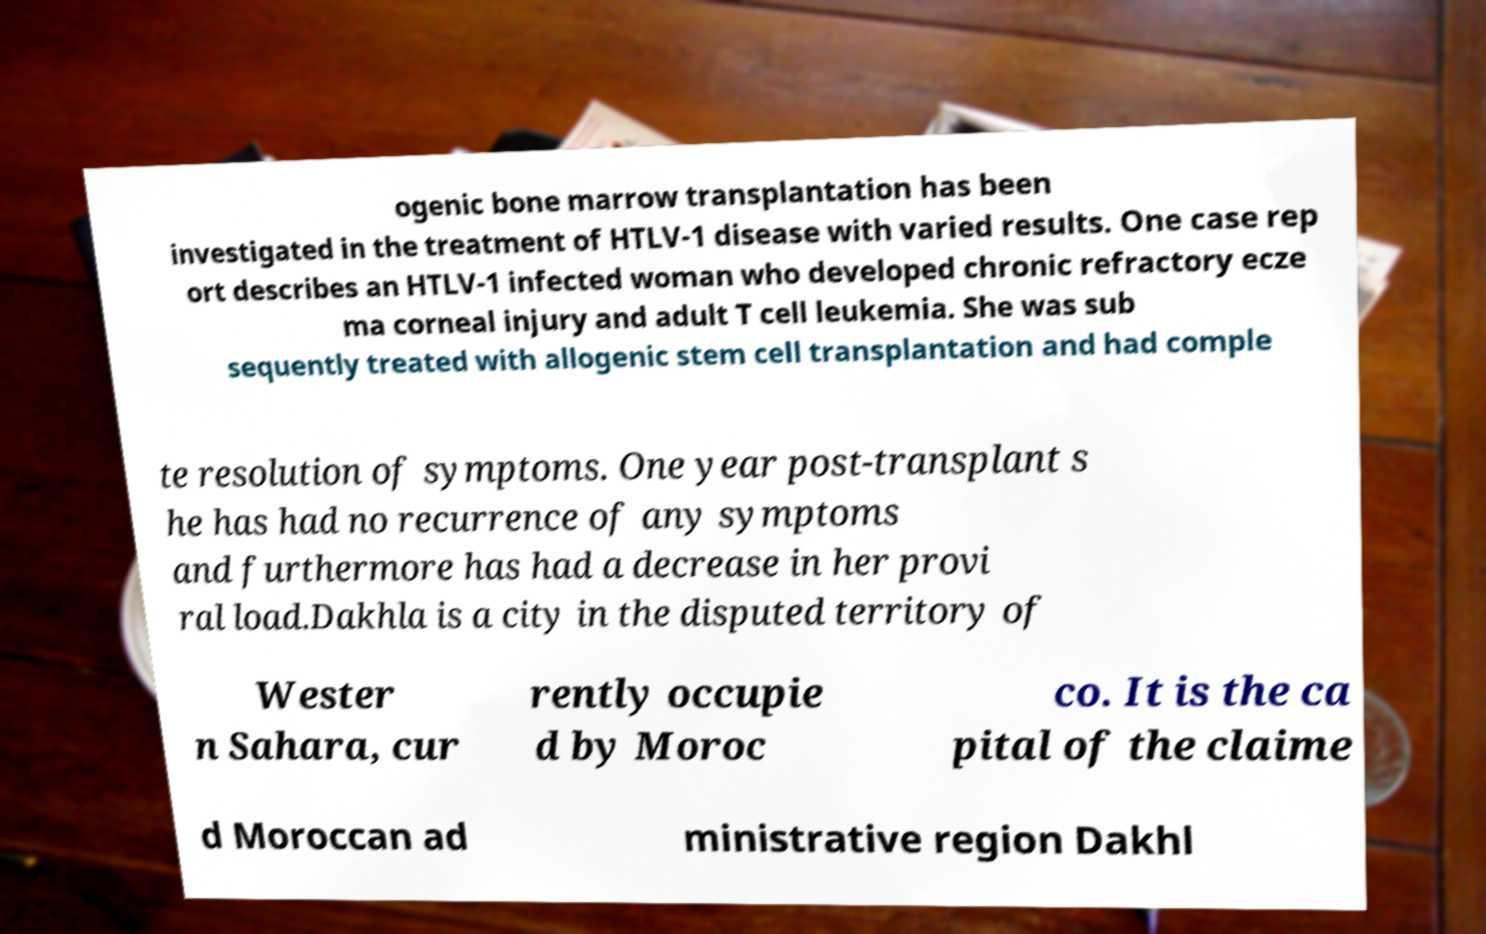What messages or text are displayed in this image? I need them in a readable, typed format. ogenic bone marrow transplantation has been investigated in the treatment of HTLV-1 disease with varied results. One case rep ort describes an HTLV-1 infected woman who developed chronic refractory ecze ma corneal injury and adult T cell leukemia. She was sub sequently treated with allogenic stem cell transplantation and had comple te resolution of symptoms. One year post-transplant s he has had no recurrence of any symptoms and furthermore has had a decrease in her provi ral load.Dakhla is a city in the disputed territory of Wester n Sahara, cur rently occupie d by Moroc co. It is the ca pital of the claime d Moroccan ad ministrative region Dakhl 